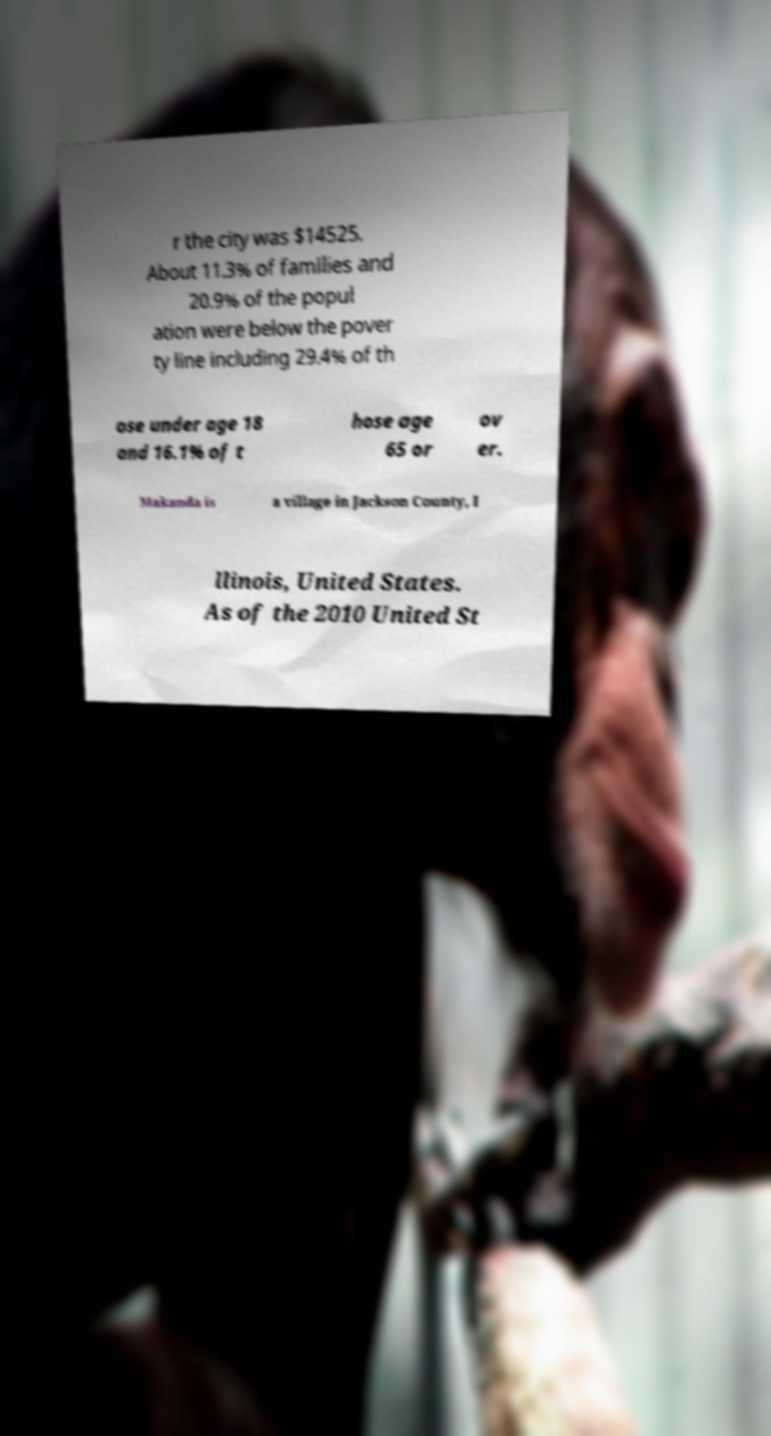Please read and relay the text visible in this image. What does it say? r the city was $14525. About 11.3% of families and 20.9% of the popul ation were below the pover ty line including 29.4% of th ose under age 18 and 16.1% of t hose age 65 or ov er. Makanda is a village in Jackson County, I llinois, United States. As of the 2010 United St 